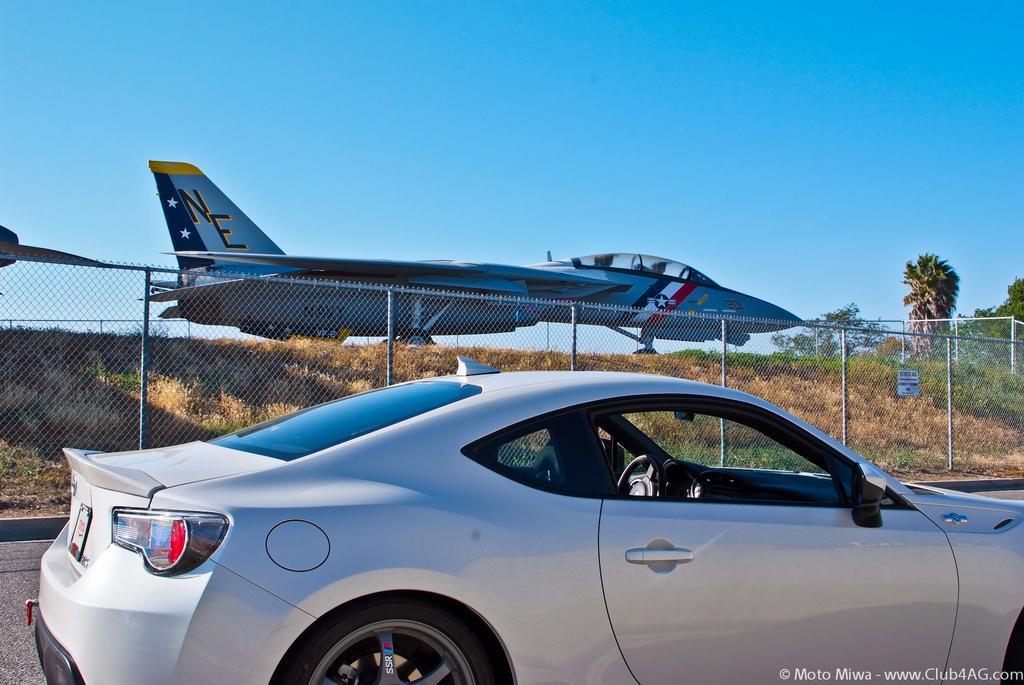Could you give a brief overview of what you see in this image? In the background we can see a clear blue sky and an airplane. In this picture we can see the trees, plants and the fence. This picture is mainly highlighted with a car on the road. In the bottom right corner of the picture we can see watermark. 